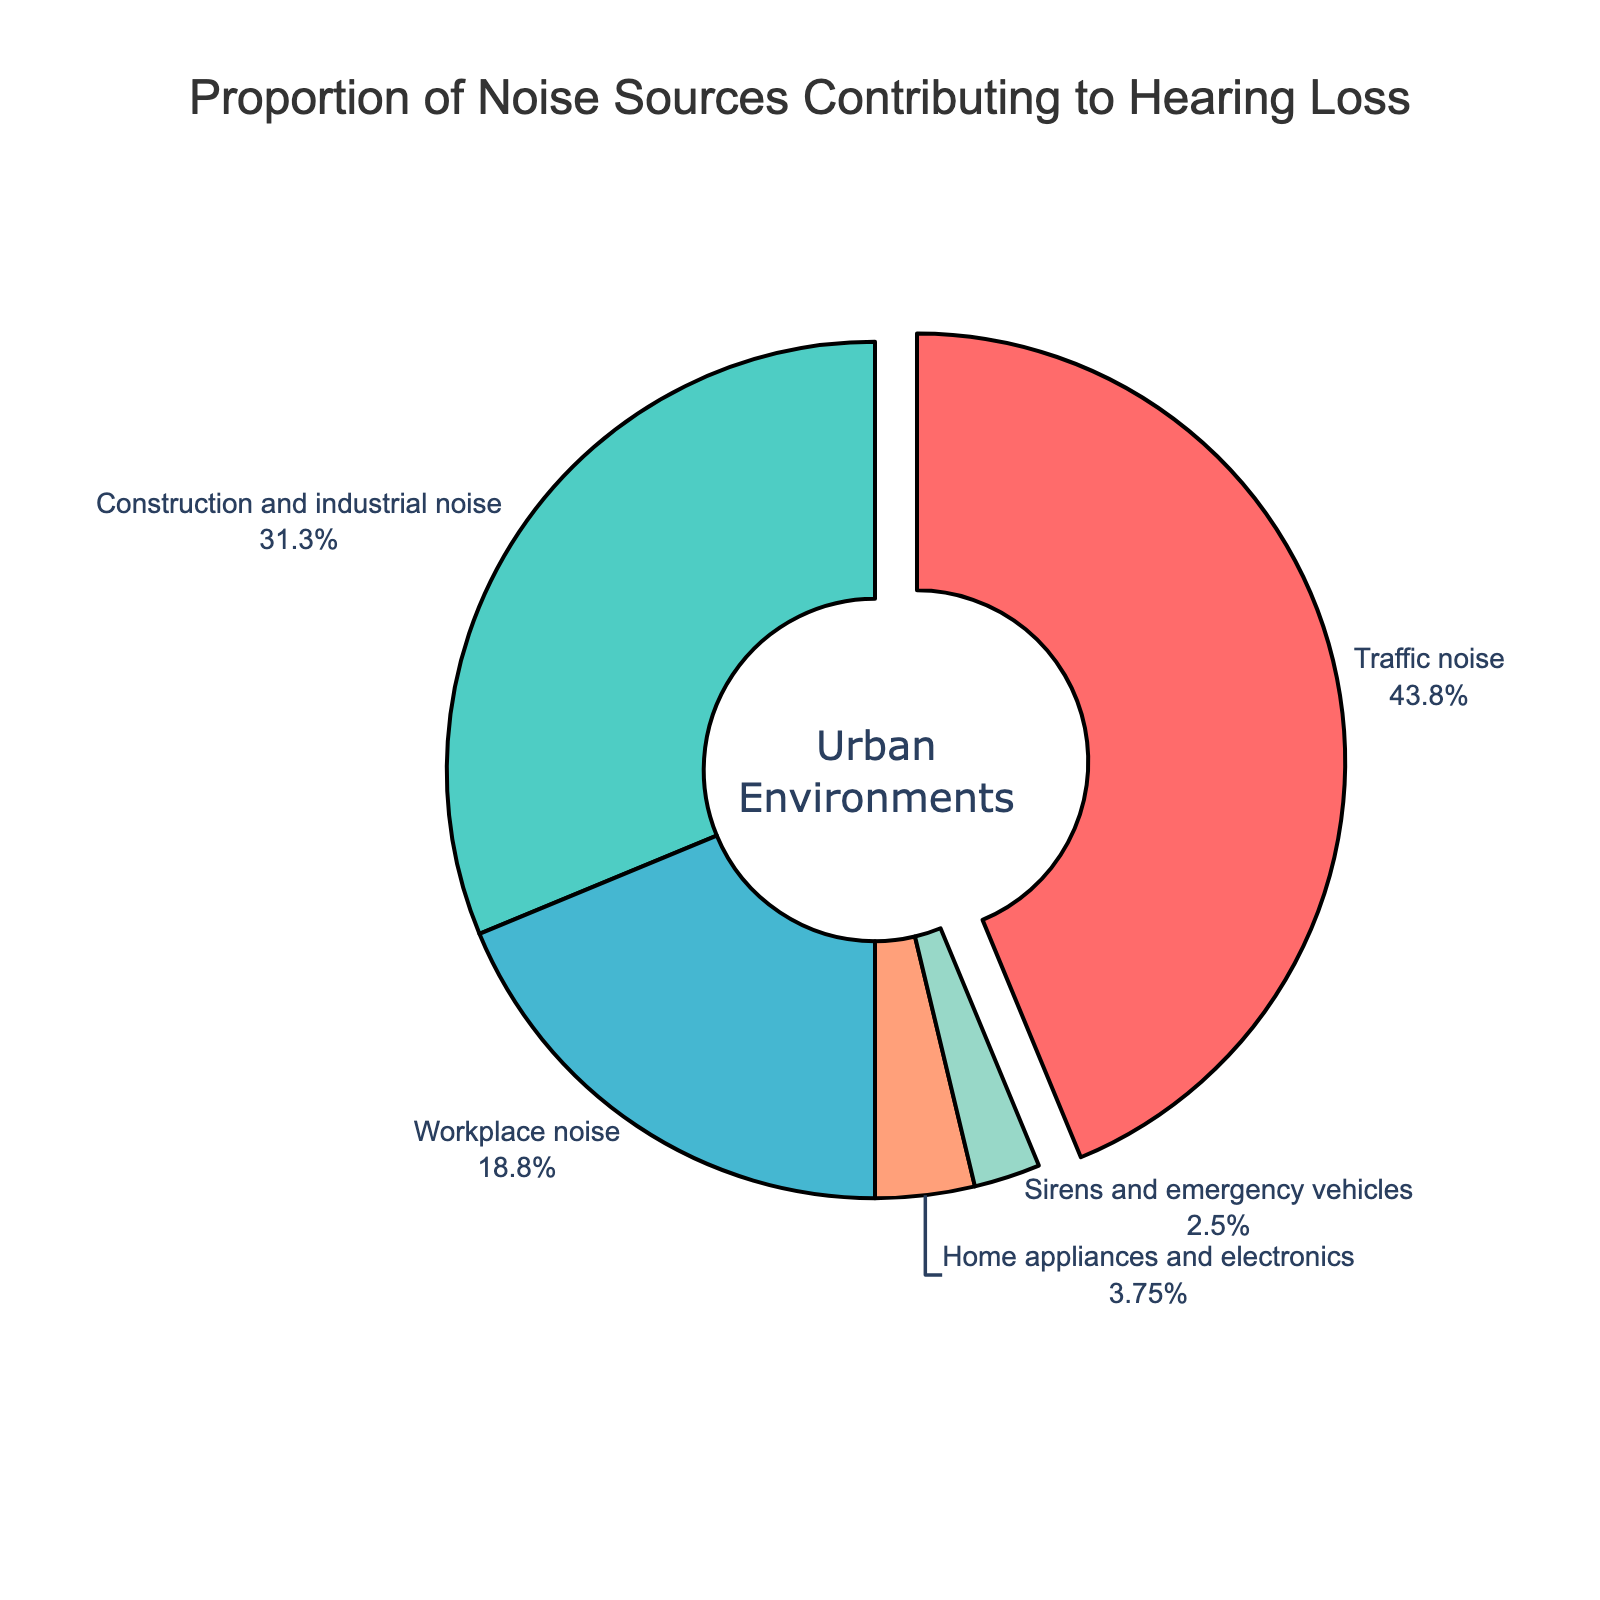What noise source contributes the most to hearing loss in urban environments? The slice representing traffic noise is the largest in the pie chart with the highest percentage.
Answer: Traffic noise What is the combined percentage of construction and industrial noise and workplace noise contributing to hearing loss? The percentages for construction and industrial noise and workplace noise are 25 and 15 respectively. Their sum is 25 + 15.
Answer: 40% Which noise source is represented by the smallest segment in the pie chart? The smallest slice in the pie chart represents sirens and emergency vehicles.
Answer: Sirens and emergency vehicles Is the proportion of home appliances and electronics noise greater than that of sirens and emergency vehicles? The percentage for home appliances and electronics is 3%, and for sirens and emergency vehicles, it is 2%. 3 > 2.
Answer: Yes What percentage of the noise contributing to hearing loss is attributed to sources other than traffic noise? Subtract the percentage of traffic noise from 100%. Traffic noise is 35%, so 100% - 35% = 65%.
Answer: 65% What is the difference in percentage between the noise contributions of traffic noise and workplace noise? The percentage for traffic noise is 35%; for workplace noise, it is 15%. The difference is 35 - 15.
Answer: 20% Are there any noise sources whose combined contribution is equal to that of construction and industrial noise? The percentage for construction and industrial noise is 25%. The sum of home appliances and electronics (3%) and sirens and emergency vehicles (2%) is 3 + 2 = 5%, and the sum of workplace noise (15%) and home appliances and electronics (3%) is 15 + 3 = 18%, neither equals 25%.
Answer: No What percentage of the pie chart is colored in red? The segment colored red represents traffic noise and its percentage is 35%.
Answer: 35% Which noise source has a contribution closest to 25% but is not equal to it? The pie chart shows workplace noise at 15%, which is the closest to 25% compared to other noise sources.
Answer: Workplace noise 